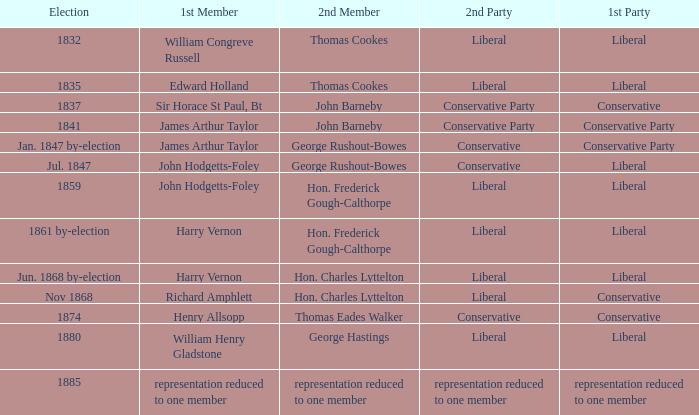What was the primary member when the inaugural party had its representation decreased to one individual? Representation reduced to one member. 